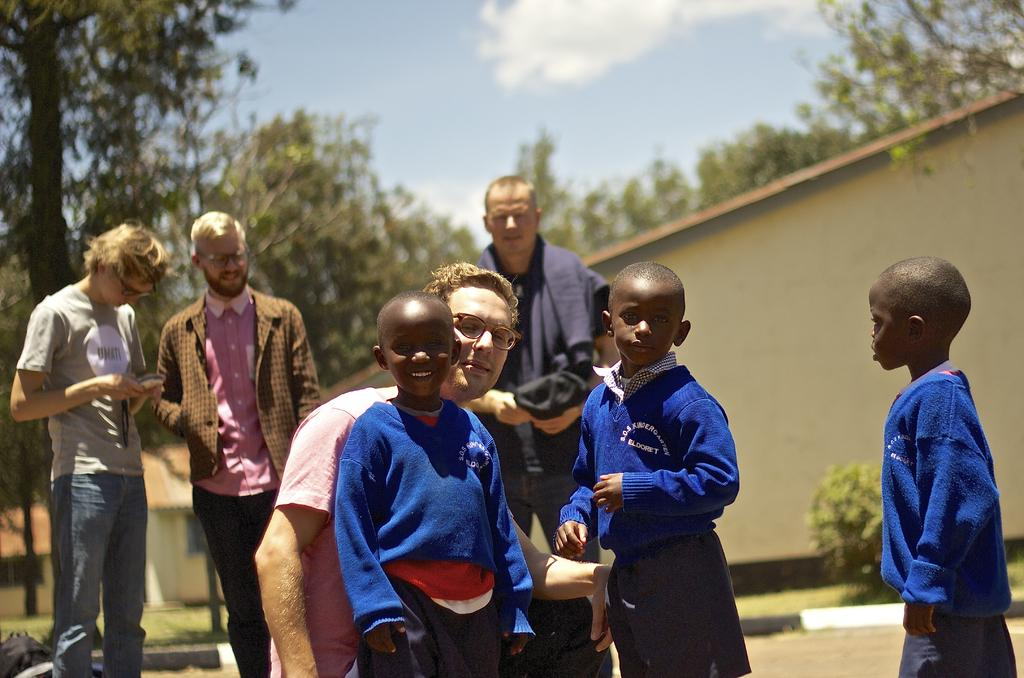Who is present in the image? There are people in the image, including children. What can be seen in the background of the image? The background of the image is blurred, but it includes trees, a wall, and a plant. What type of haircut does the plant have in the image? There is no haircut present in the image, as the plant is not a person or animal. 